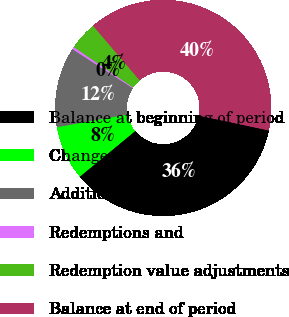Convert chart to OTSL. <chart><loc_0><loc_0><loc_500><loc_500><pie_chart><fcel>Balance at beginning of period<fcel>Change in related<fcel>Additions<fcel>Redemptions and<fcel>Redemption value adjustments<fcel>Balance at end of period<nl><fcel>35.7%<fcel>8.12%<fcel>12.0%<fcel>0.36%<fcel>4.24%<fcel>39.58%<nl></chart> 